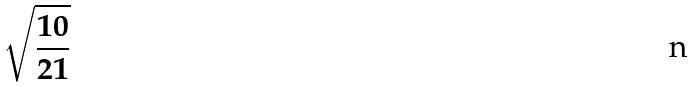<formula> <loc_0><loc_0><loc_500><loc_500>\sqrt { \frac { 1 0 } { 2 1 } }</formula> 